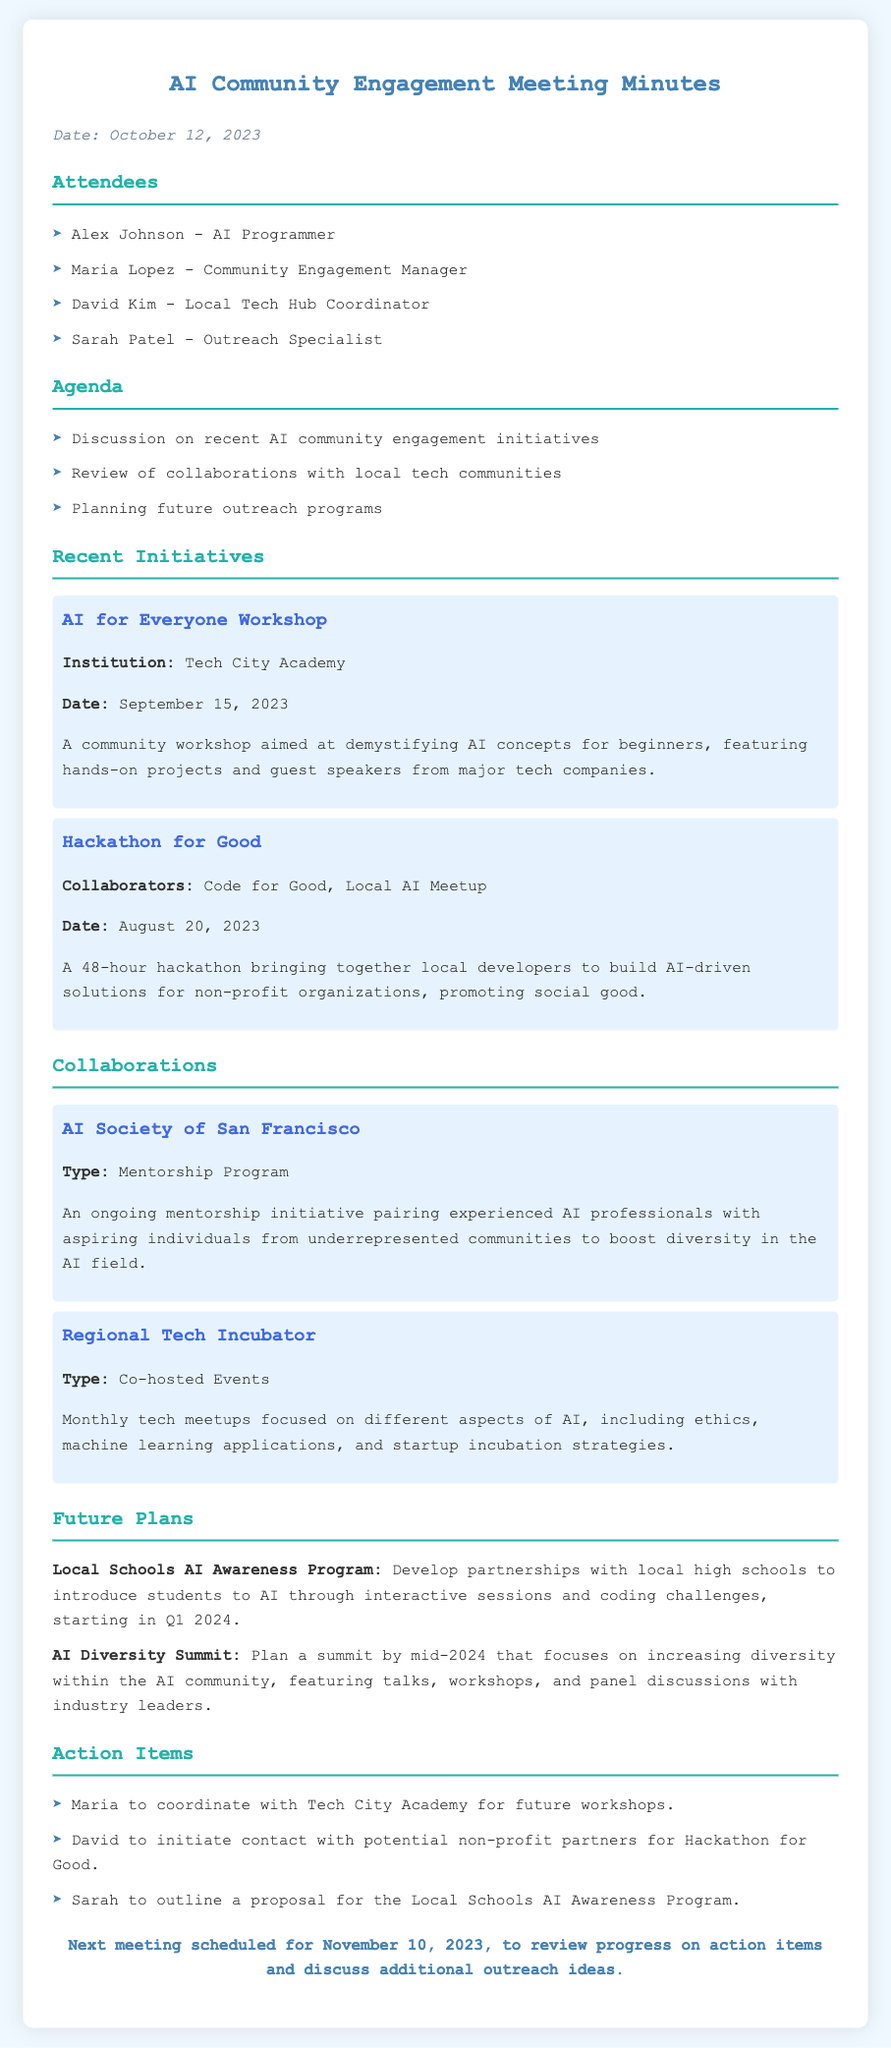what is the date of the meeting? The date of the meeting is mentioned in the introduction section of the document.
Answer: October 12, 2023 who is the Community Engagement Manager? The name of the Community Engagement Manager is listed in the attendees section of the document.
Answer: Maria Lopez what is the title of the workshop held on September 15, 2023? The title of the workshop is found in the section detailing recent initiatives.
Answer: AI for Everyone Workshop how many action items are listed? The action items are enumerated under the action items section of the document.
Answer: 3 which organization collaborated on the Hackathon for Good? The collaborators for the Hackathon for Good are mentioned in the recent initiatives section.
Answer: Code for Good, Local AI Meetup what type of program is the mentorship initiative with the AI Society of San Francisco? The type of program is indicated in the collaborations section of the document.
Answer: Mentorship Program when is the next meeting scheduled? The date for the next meeting is provided towards the end of the document.
Answer: November 10, 2023 what is the focus of the future AI Diversity Summit? The focus of the summit is summarized in the future plans section of the document.
Answer: Increasing diversity within the AI community 